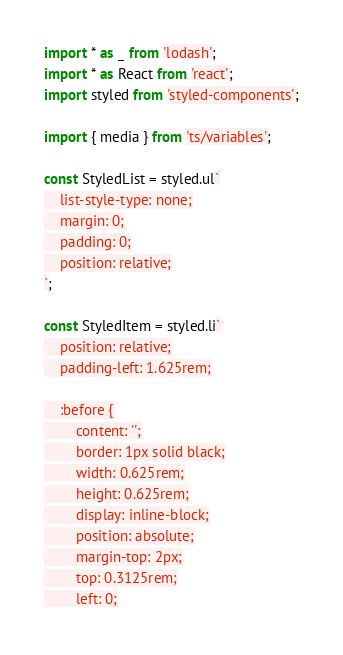<code> <loc_0><loc_0><loc_500><loc_500><_TypeScript_>import * as _ from 'lodash';
import * as React from 'react';
import styled from 'styled-components';

import { media } from 'ts/variables';

const StyledList = styled.ul`
    list-style-type: none;
    margin: 0;
    padding: 0;
    position: relative;
`;

const StyledItem = styled.li`
    position: relative;
    padding-left: 1.625rem;

    :before {
        content: '';
        border: 1px solid black;
        width: 0.625rem;
        height: 0.625rem;
        display: inline-block;
        position: absolute;
        margin-top: 2px;
        top: 0.3125rem;
        left: 0;</code> 